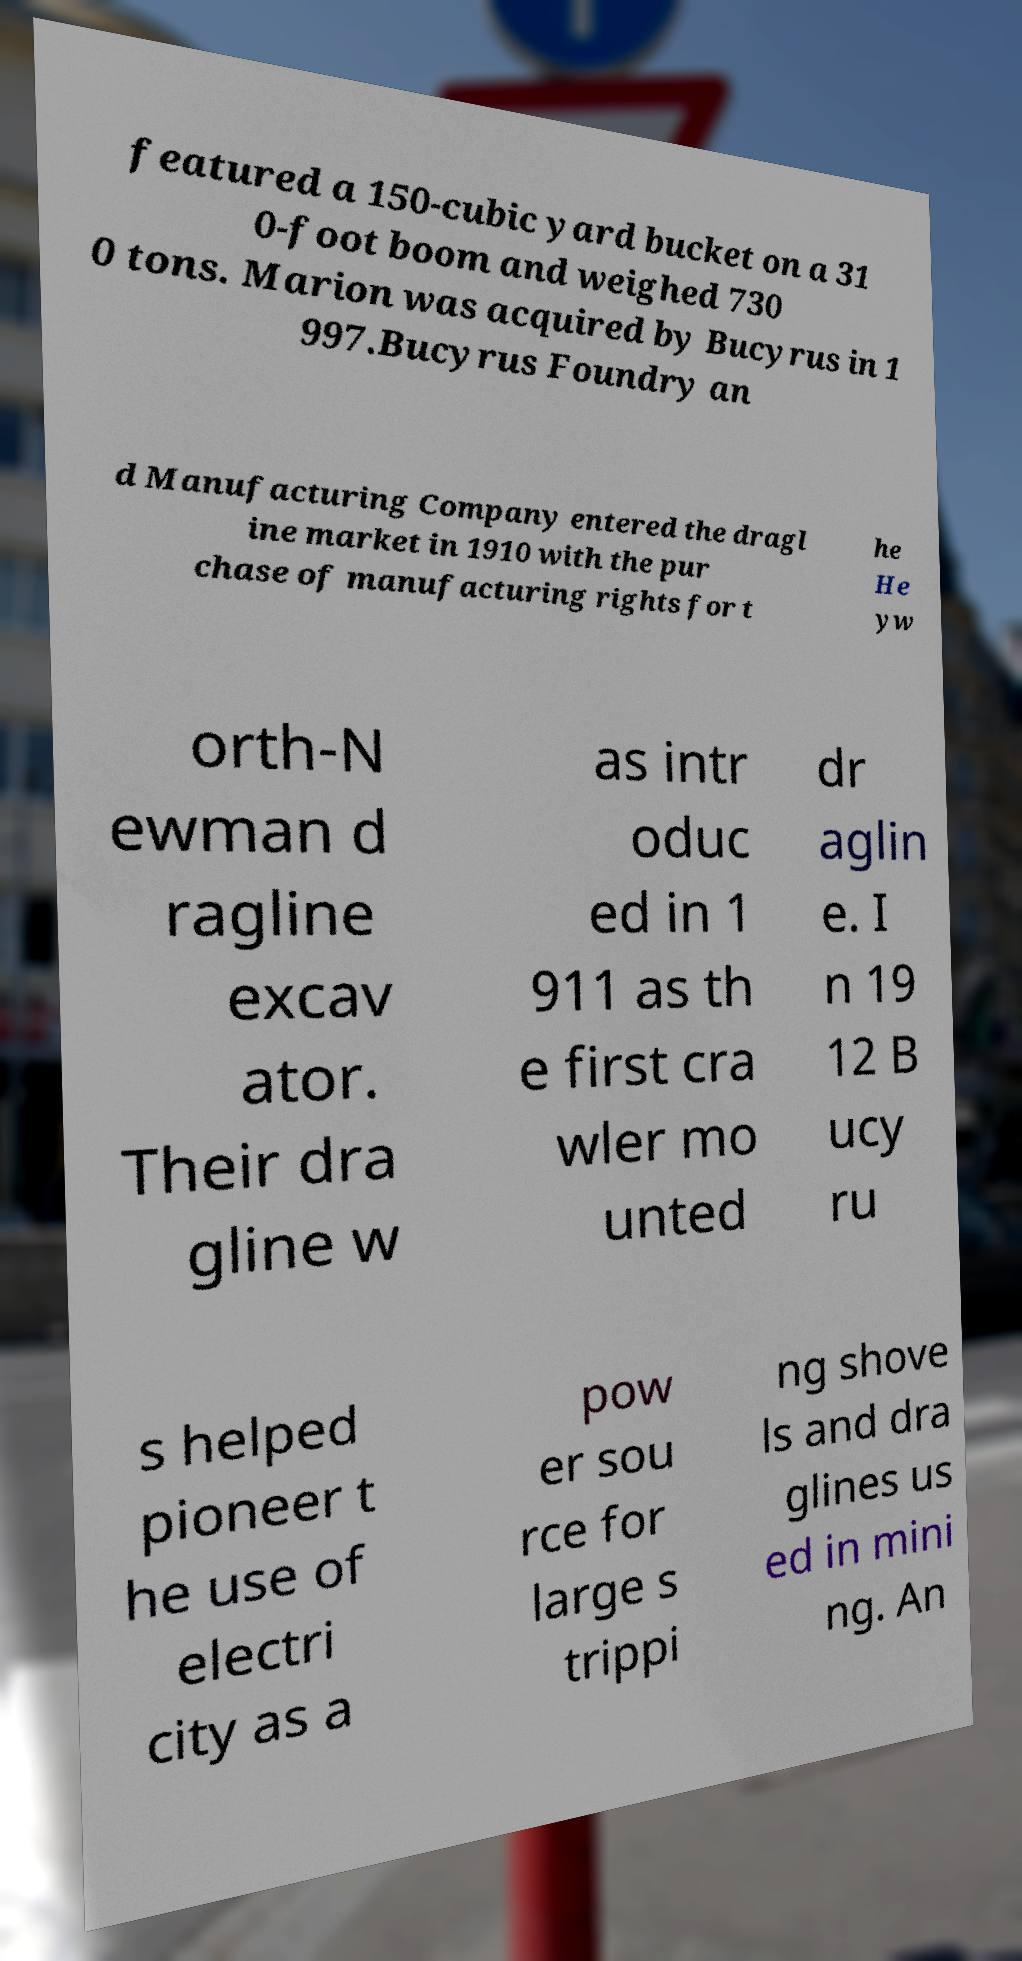Can you accurately transcribe the text from the provided image for me? featured a 150-cubic yard bucket on a 31 0-foot boom and weighed 730 0 tons. Marion was acquired by Bucyrus in 1 997.Bucyrus Foundry an d Manufacturing Company entered the dragl ine market in 1910 with the pur chase of manufacturing rights for t he He yw orth-N ewman d ragline excav ator. Their dra gline w as intr oduc ed in 1 911 as th e first cra wler mo unted dr aglin e. I n 19 12 B ucy ru s helped pioneer t he use of electri city as a pow er sou rce for large s trippi ng shove ls and dra glines us ed in mini ng. An 